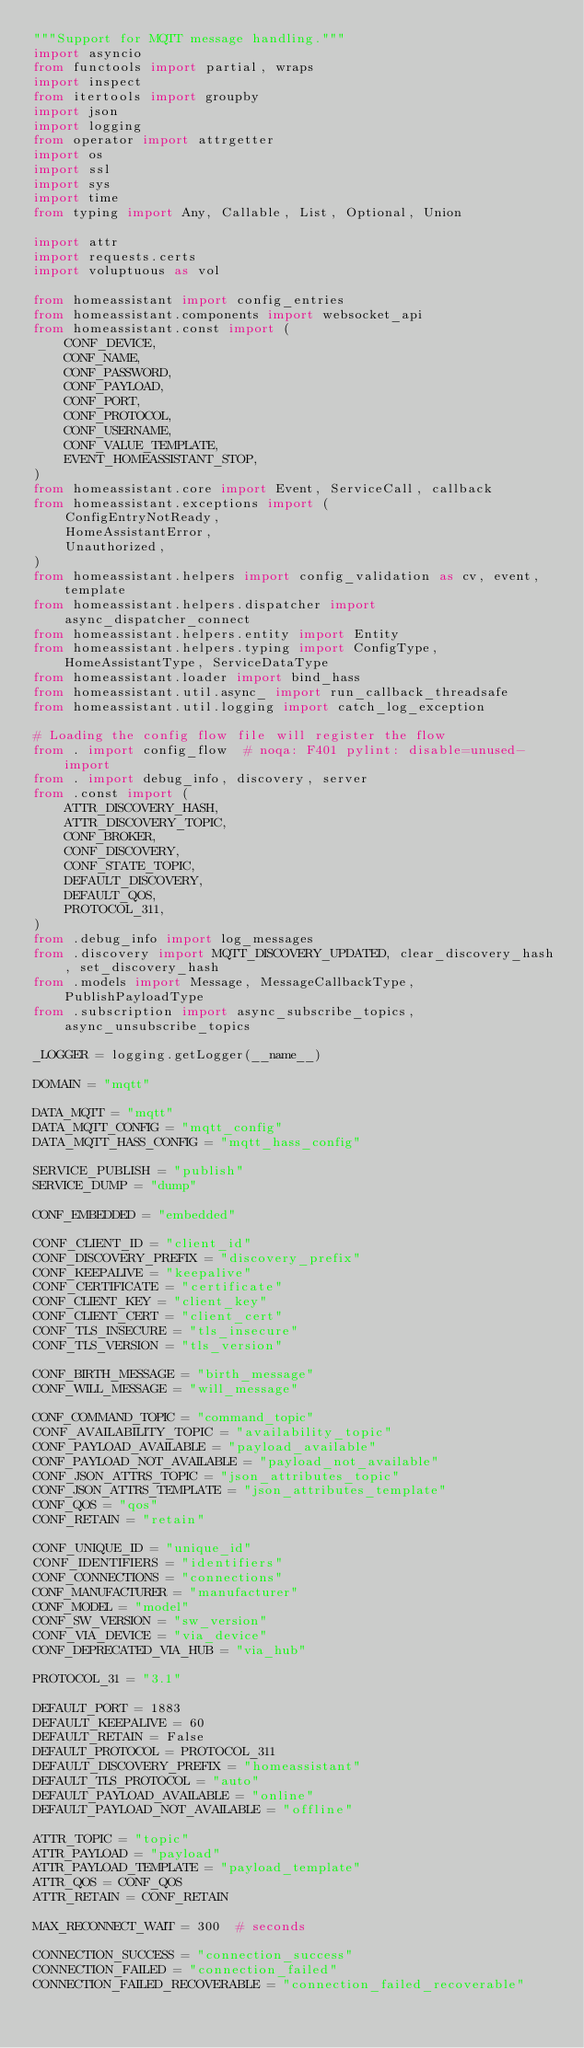<code> <loc_0><loc_0><loc_500><loc_500><_Python_>"""Support for MQTT message handling."""
import asyncio
from functools import partial, wraps
import inspect
from itertools import groupby
import json
import logging
from operator import attrgetter
import os
import ssl
import sys
import time
from typing import Any, Callable, List, Optional, Union

import attr
import requests.certs
import voluptuous as vol

from homeassistant import config_entries
from homeassistant.components import websocket_api
from homeassistant.const import (
    CONF_DEVICE,
    CONF_NAME,
    CONF_PASSWORD,
    CONF_PAYLOAD,
    CONF_PORT,
    CONF_PROTOCOL,
    CONF_USERNAME,
    CONF_VALUE_TEMPLATE,
    EVENT_HOMEASSISTANT_STOP,
)
from homeassistant.core import Event, ServiceCall, callback
from homeassistant.exceptions import (
    ConfigEntryNotReady,
    HomeAssistantError,
    Unauthorized,
)
from homeassistant.helpers import config_validation as cv, event, template
from homeassistant.helpers.dispatcher import async_dispatcher_connect
from homeassistant.helpers.entity import Entity
from homeassistant.helpers.typing import ConfigType, HomeAssistantType, ServiceDataType
from homeassistant.loader import bind_hass
from homeassistant.util.async_ import run_callback_threadsafe
from homeassistant.util.logging import catch_log_exception

# Loading the config flow file will register the flow
from . import config_flow  # noqa: F401 pylint: disable=unused-import
from . import debug_info, discovery, server
from .const import (
    ATTR_DISCOVERY_HASH,
    ATTR_DISCOVERY_TOPIC,
    CONF_BROKER,
    CONF_DISCOVERY,
    CONF_STATE_TOPIC,
    DEFAULT_DISCOVERY,
    DEFAULT_QOS,
    PROTOCOL_311,
)
from .debug_info import log_messages
from .discovery import MQTT_DISCOVERY_UPDATED, clear_discovery_hash, set_discovery_hash
from .models import Message, MessageCallbackType, PublishPayloadType
from .subscription import async_subscribe_topics, async_unsubscribe_topics

_LOGGER = logging.getLogger(__name__)

DOMAIN = "mqtt"

DATA_MQTT = "mqtt"
DATA_MQTT_CONFIG = "mqtt_config"
DATA_MQTT_HASS_CONFIG = "mqtt_hass_config"

SERVICE_PUBLISH = "publish"
SERVICE_DUMP = "dump"

CONF_EMBEDDED = "embedded"

CONF_CLIENT_ID = "client_id"
CONF_DISCOVERY_PREFIX = "discovery_prefix"
CONF_KEEPALIVE = "keepalive"
CONF_CERTIFICATE = "certificate"
CONF_CLIENT_KEY = "client_key"
CONF_CLIENT_CERT = "client_cert"
CONF_TLS_INSECURE = "tls_insecure"
CONF_TLS_VERSION = "tls_version"

CONF_BIRTH_MESSAGE = "birth_message"
CONF_WILL_MESSAGE = "will_message"

CONF_COMMAND_TOPIC = "command_topic"
CONF_AVAILABILITY_TOPIC = "availability_topic"
CONF_PAYLOAD_AVAILABLE = "payload_available"
CONF_PAYLOAD_NOT_AVAILABLE = "payload_not_available"
CONF_JSON_ATTRS_TOPIC = "json_attributes_topic"
CONF_JSON_ATTRS_TEMPLATE = "json_attributes_template"
CONF_QOS = "qos"
CONF_RETAIN = "retain"

CONF_UNIQUE_ID = "unique_id"
CONF_IDENTIFIERS = "identifiers"
CONF_CONNECTIONS = "connections"
CONF_MANUFACTURER = "manufacturer"
CONF_MODEL = "model"
CONF_SW_VERSION = "sw_version"
CONF_VIA_DEVICE = "via_device"
CONF_DEPRECATED_VIA_HUB = "via_hub"

PROTOCOL_31 = "3.1"

DEFAULT_PORT = 1883
DEFAULT_KEEPALIVE = 60
DEFAULT_RETAIN = False
DEFAULT_PROTOCOL = PROTOCOL_311
DEFAULT_DISCOVERY_PREFIX = "homeassistant"
DEFAULT_TLS_PROTOCOL = "auto"
DEFAULT_PAYLOAD_AVAILABLE = "online"
DEFAULT_PAYLOAD_NOT_AVAILABLE = "offline"

ATTR_TOPIC = "topic"
ATTR_PAYLOAD = "payload"
ATTR_PAYLOAD_TEMPLATE = "payload_template"
ATTR_QOS = CONF_QOS
ATTR_RETAIN = CONF_RETAIN

MAX_RECONNECT_WAIT = 300  # seconds

CONNECTION_SUCCESS = "connection_success"
CONNECTION_FAILED = "connection_failed"
CONNECTION_FAILED_RECOVERABLE = "connection_failed_recoverable"

</code> 